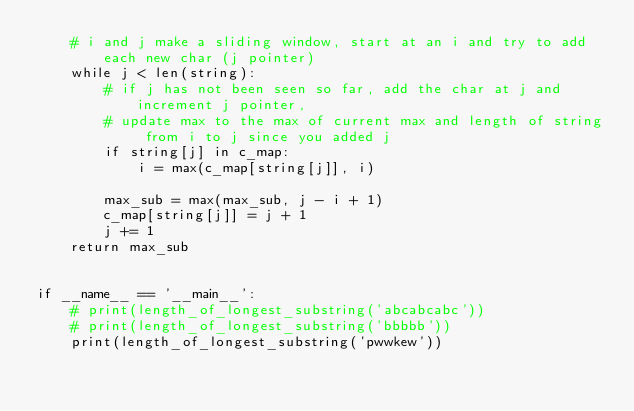Convert code to text. <code><loc_0><loc_0><loc_500><loc_500><_Python_>    # i and j make a sliding window, start at an i and try to add each new char (j pointer)
    while j < len(string):
        # if j has not been seen so far, add the char at j and increment j pointer,
        # update max to the max of current max and length of string from i to j since you added j
        if string[j] in c_map:
            i = max(c_map[string[j]], i)

        max_sub = max(max_sub, j - i + 1)
        c_map[string[j]] = j + 1
        j += 1
    return max_sub


if __name__ == '__main__':
    # print(length_of_longest_substring('abcabcabc'))
    # print(length_of_longest_substring('bbbbb'))
    print(length_of_longest_substring('pwwkew'))
</code> 